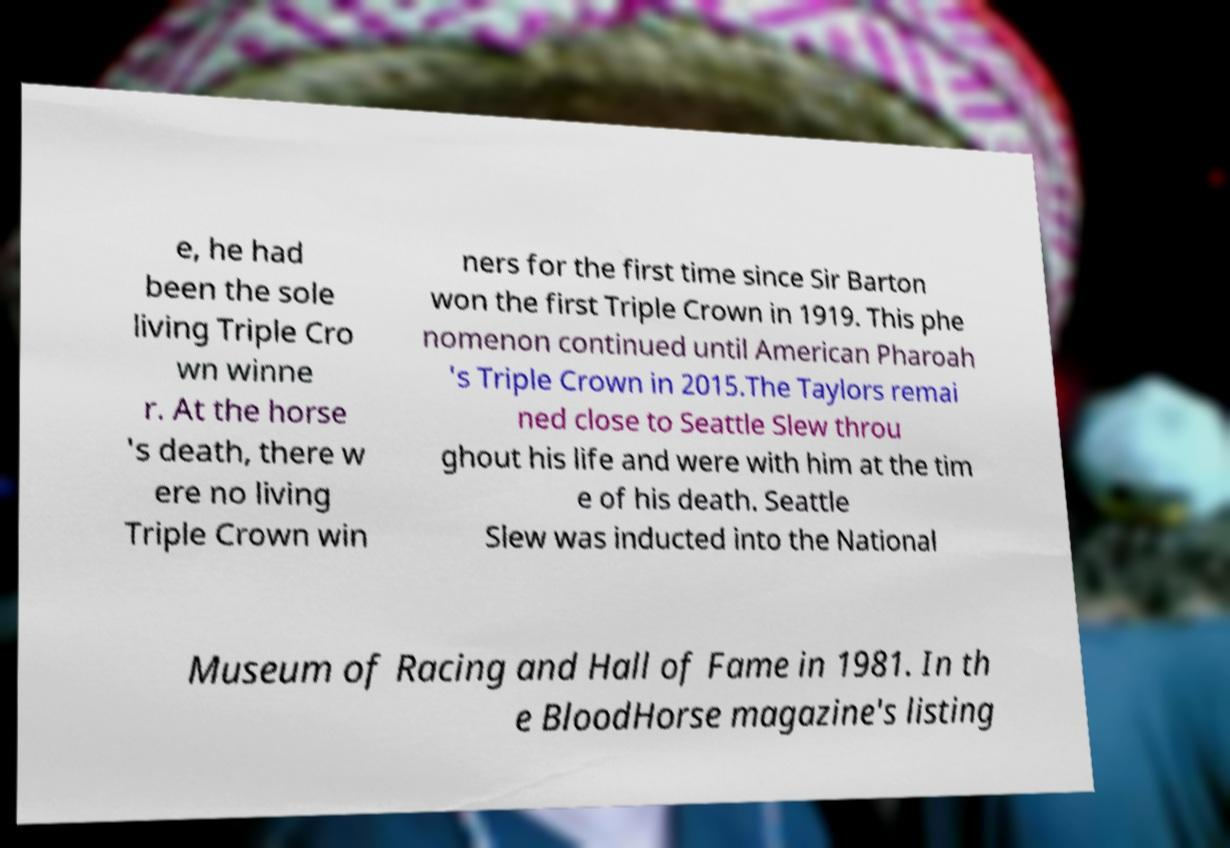Can you accurately transcribe the text from the provided image for me? e, he had been the sole living Triple Cro wn winne r. At the horse 's death, there w ere no living Triple Crown win ners for the first time since Sir Barton won the first Triple Crown in 1919. This phe nomenon continued until American Pharoah 's Triple Crown in 2015.The Taylors remai ned close to Seattle Slew throu ghout his life and were with him at the tim e of his death. Seattle Slew was inducted into the National Museum of Racing and Hall of Fame in 1981. In th e BloodHorse magazine's listing 